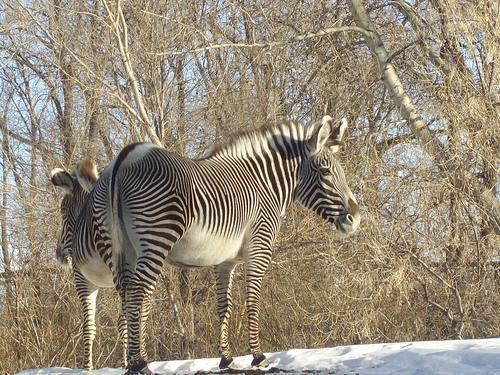How many zebras are in picture?
Give a very brief answer. 2. 